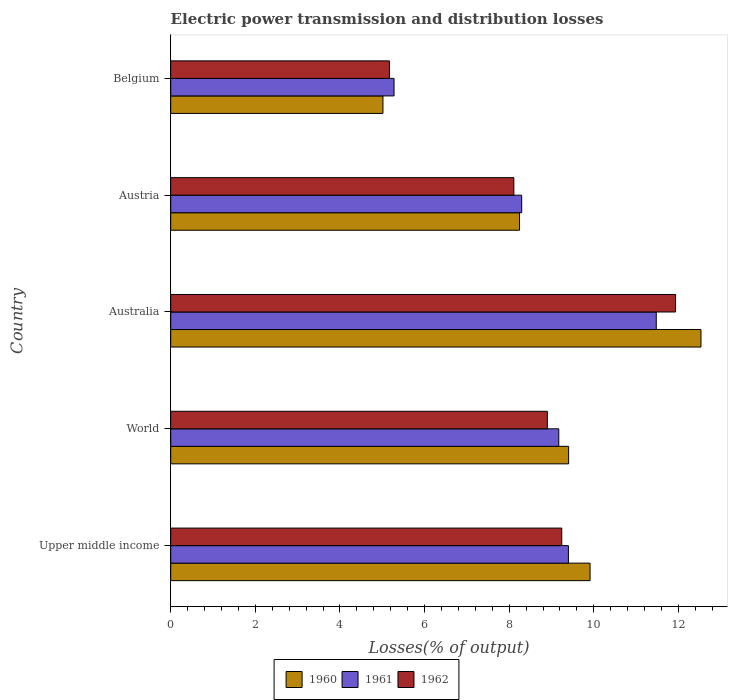How many different coloured bars are there?
Ensure brevity in your answer.  3. How many groups of bars are there?
Your answer should be very brief. 5. How many bars are there on the 4th tick from the top?
Provide a short and direct response. 3. What is the label of the 5th group of bars from the top?
Offer a very short reply. Upper middle income. What is the electric power transmission and distribution losses in 1960 in Australia?
Provide a short and direct response. 12.53. Across all countries, what is the maximum electric power transmission and distribution losses in 1962?
Provide a succinct answer. 11.93. Across all countries, what is the minimum electric power transmission and distribution losses in 1960?
Provide a succinct answer. 5.02. In which country was the electric power transmission and distribution losses in 1960 maximum?
Provide a succinct answer. Australia. In which country was the electric power transmission and distribution losses in 1960 minimum?
Offer a very short reply. Belgium. What is the total electric power transmission and distribution losses in 1961 in the graph?
Make the answer very short. 43.62. What is the difference between the electric power transmission and distribution losses in 1961 in Belgium and that in Upper middle income?
Provide a succinct answer. -4.12. What is the difference between the electric power transmission and distribution losses in 1961 in World and the electric power transmission and distribution losses in 1960 in Austria?
Keep it short and to the point. 0.93. What is the average electric power transmission and distribution losses in 1961 per country?
Your answer should be compact. 8.72. What is the difference between the electric power transmission and distribution losses in 1962 and electric power transmission and distribution losses in 1960 in Belgium?
Ensure brevity in your answer.  0.15. What is the ratio of the electric power transmission and distribution losses in 1962 in Belgium to that in Upper middle income?
Ensure brevity in your answer.  0.56. What is the difference between the highest and the second highest electric power transmission and distribution losses in 1960?
Give a very brief answer. 2.62. What is the difference between the highest and the lowest electric power transmission and distribution losses in 1962?
Your response must be concise. 6.76. In how many countries, is the electric power transmission and distribution losses in 1961 greater than the average electric power transmission and distribution losses in 1961 taken over all countries?
Make the answer very short. 3. What does the 2nd bar from the top in Austria represents?
Offer a terse response. 1961. Is it the case that in every country, the sum of the electric power transmission and distribution losses in 1960 and electric power transmission and distribution losses in 1961 is greater than the electric power transmission and distribution losses in 1962?
Your answer should be very brief. Yes. How many bars are there?
Give a very brief answer. 15. Are all the bars in the graph horizontal?
Give a very brief answer. Yes. Does the graph contain grids?
Make the answer very short. No. How are the legend labels stacked?
Your answer should be compact. Horizontal. What is the title of the graph?
Your answer should be very brief. Electric power transmission and distribution losses. What is the label or title of the X-axis?
Keep it short and to the point. Losses(% of output). What is the Losses(% of output) in 1960 in Upper middle income?
Ensure brevity in your answer.  9.91. What is the Losses(% of output) of 1961 in Upper middle income?
Your answer should be very brief. 9.4. What is the Losses(% of output) in 1962 in Upper middle income?
Provide a succinct answer. 9.24. What is the Losses(% of output) in 1960 in World?
Offer a very short reply. 9.4. What is the Losses(% of output) in 1961 in World?
Your answer should be very brief. 9.17. What is the Losses(% of output) in 1962 in World?
Give a very brief answer. 8.9. What is the Losses(% of output) of 1960 in Australia?
Your answer should be very brief. 12.53. What is the Losses(% of output) of 1961 in Australia?
Keep it short and to the point. 11.48. What is the Losses(% of output) of 1962 in Australia?
Ensure brevity in your answer.  11.93. What is the Losses(% of output) in 1960 in Austria?
Keep it short and to the point. 8.24. What is the Losses(% of output) in 1961 in Austria?
Keep it short and to the point. 8.3. What is the Losses(% of output) of 1962 in Austria?
Your response must be concise. 8.11. What is the Losses(% of output) in 1960 in Belgium?
Make the answer very short. 5.02. What is the Losses(% of output) in 1961 in Belgium?
Ensure brevity in your answer.  5.28. What is the Losses(% of output) in 1962 in Belgium?
Provide a short and direct response. 5.17. Across all countries, what is the maximum Losses(% of output) of 1960?
Keep it short and to the point. 12.53. Across all countries, what is the maximum Losses(% of output) in 1961?
Make the answer very short. 11.48. Across all countries, what is the maximum Losses(% of output) in 1962?
Offer a terse response. 11.93. Across all countries, what is the minimum Losses(% of output) in 1960?
Your answer should be very brief. 5.02. Across all countries, what is the minimum Losses(% of output) in 1961?
Ensure brevity in your answer.  5.28. Across all countries, what is the minimum Losses(% of output) of 1962?
Offer a very short reply. 5.17. What is the total Losses(% of output) in 1960 in the graph?
Keep it short and to the point. 45.11. What is the total Losses(% of output) in 1961 in the graph?
Your answer should be very brief. 43.62. What is the total Losses(% of output) in 1962 in the graph?
Your answer should be very brief. 43.35. What is the difference between the Losses(% of output) in 1960 in Upper middle income and that in World?
Make the answer very short. 0.51. What is the difference between the Losses(% of output) of 1961 in Upper middle income and that in World?
Make the answer very short. 0.23. What is the difference between the Losses(% of output) of 1962 in Upper middle income and that in World?
Ensure brevity in your answer.  0.34. What is the difference between the Losses(% of output) in 1960 in Upper middle income and that in Australia?
Your answer should be compact. -2.62. What is the difference between the Losses(% of output) in 1961 in Upper middle income and that in Australia?
Keep it short and to the point. -2.08. What is the difference between the Losses(% of output) of 1962 in Upper middle income and that in Australia?
Ensure brevity in your answer.  -2.69. What is the difference between the Losses(% of output) in 1960 in Upper middle income and that in Austria?
Offer a very short reply. 1.67. What is the difference between the Losses(% of output) of 1961 in Upper middle income and that in Austria?
Provide a succinct answer. 1.1. What is the difference between the Losses(% of output) in 1962 in Upper middle income and that in Austria?
Provide a short and direct response. 1.13. What is the difference between the Losses(% of output) of 1960 in Upper middle income and that in Belgium?
Your answer should be compact. 4.9. What is the difference between the Losses(% of output) in 1961 in Upper middle income and that in Belgium?
Make the answer very short. 4.12. What is the difference between the Losses(% of output) in 1962 in Upper middle income and that in Belgium?
Provide a succinct answer. 4.07. What is the difference between the Losses(% of output) of 1960 in World and that in Australia?
Offer a terse response. -3.13. What is the difference between the Losses(% of output) in 1961 in World and that in Australia?
Provide a short and direct response. -2.3. What is the difference between the Losses(% of output) of 1962 in World and that in Australia?
Your response must be concise. -3.03. What is the difference between the Losses(% of output) of 1960 in World and that in Austria?
Keep it short and to the point. 1.16. What is the difference between the Losses(% of output) in 1961 in World and that in Austria?
Your answer should be compact. 0.88. What is the difference between the Losses(% of output) in 1962 in World and that in Austria?
Provide a succinct answer. 0.79. What is the difference between the Losses(% of output) of 1960 in World and that in Belgium?
Offer a terse response. 4.39. What is the difference between the Losses(% of output) of 1961 in World and that in Belgium?
Your answer should be compact. 3.89. What is the difference between the Losses(% of output) of 1962 in World and that in Belgium?
Keep it short and to the point. 3.73. What is the difference between the Losses(% of output) of 1960 in Australia and that in Austria?
Make the answer very short. 4.29. What is the difference between the Losses(% of output) in 1961 in Australia and that in Austria?
Offer a terse response. 3.18. What is the difference between the Losses(% of output) of 1962 in Australia and that in Austria?
Your response must be concise. 3.82. What is the difference between the Losses(% of output) in 1960 in Australia and that in Belgium?
Your answer should be compact. 7.52. What is the difference between the Losses(% of output) in 1961 in Australia and that in Belgium?
Provide a short and direct response. 6.2. What is the difference between the Losses(% of output) in 1962 in Australia and that in Belgium?
Keep it short and to the point. 6.76. What is the difference between the Losses(% of output) of 1960 in Austria and that in Belgium?
Provide a short and direct response. 3.23. What is the difference between the Losses(% of output) in 1961 in Austria and that in Belgium?
Offer a terse response. 3.02. What is the difference between the Losses(% of output) of 1962 in Austria and that in Belgium?
Ensure brevity in your answer.  2.94. What is the difference between the Losses(% of output) of 1960 in Upper middle income and the Losses(% of output) of 1961 in World?
Offer a terse response. 0.74. What is the difference between the Losses(% of output) in 1960 in Upper middle income and the Losses(% of output) in 1962 in World?
Give a very brief answer. 1.01. What is the difference between the Losses(% of output) in 1961 in Upper middle income and the Losses(% of output) in 1962 in World?
Ensure brevity in your answer.  0.5. What is the difference between the Losses(% of output) of 1960 in Upper middle income and the Losses(% of output) of 1961 in Australia?
Your answer should be very brief. -1.56. What is the difference between the Losses(% of output) in 1960 in Upper middle income and the Losses(% of output) in 1962 in Australia?
Your answer should be very brief. -2.02. What is the difference between the Losses(% of output) of 1961 in Upper middle income and the Losses(% of output) of 1962 in Australia?
Give a very brief answer. -2.53. What is the difference between the Losses(% of output) in 1960 in Upper middle income and the Losses(% of output) in 1961 in Austria?
Keep it short and to the point. 1.62. What is the difference between the Losses(% of output) in 1960 in Upper middle income and the Losses(% of output) in 1962 in Austria?
Your answer should be compact. 1.8. What is the difference between the Losses(% of output) of 1961 in Upper middle income and the Losses(% of output) of 1962 in Austria?
Your answer should be compact. 1.29. What is the difference between the Losses(% of output) of 1960 in Upper middle income and the Losses(% of output) of 1961 in Belgium?
Make the answer very short. 4.63. What is the difference between the Losses(% of output) in 1960 in Upper middle income and the Losses(% of output) in 1962 in Belgium?
Give a very brief answer. 4.74. What is the difference between the Losses(% of output) in 1961 in Upper middle income and the Losses(% of output) in 1962 in Belgium?
Your response must be concise. 4.23. What is the difference between the Losses(% of output) of 1960 in World and the Losses(% of output) of 1961 in Australia?
Ensure brevity in your answer.  -2.07. What is the difference between the Losses(% of output) of 1960 in World and the Losses(% of output) of 1962 in Australia?
Your answer should be very brief. -2.53. What is the difference between the Losses(% of output) in 1961 in World and the Losses(% of output) in 1962 in Australia?
Provide a succinct answer. -2.76. What is the difference between the Losses(% of output) in 1960 in World and the Losses(% of output) in 1961 in Austria?
Keep it short and to the point. 1.11. What is the difference between the Losses(% of output) of 1960 in World and the Losses(% of output) of 1962 in Austria?
Offer a very short reply. 1.29. What is the difference between the Losses(% of output) in 1961 in World and the Losses(% of output) in 1962 in Austria?
Provide a succinct answer. 1.06. What is the difference between the Losses(% of output) of 1960 in World and the Losses(% of output) of 1961 in Belgium?
Your answer should be very brief. 4.13. What is the difference between the Losses(% of output) in 1960 in World and the Losses(% of output) in 1962 in Belgium?
Your answer should be very brief. 4.23. What is the difference between the Losses(% of output) of 1961 in World and the Losses(% of output) of 1962 in Belgium?
Offer a very short reply. 4. What is the difference between the Losses(% of output) of 1960 in Australia and the Losses(% of output) of 1961 in Austria?
Offer a very short reply. 4.24. What is the difference between the Losses(% of output) of 1960 in Australia and the Losses(% of output) of 1962 in Austria?
Make the answer very short. 4.42. What is the difference between the Losses(% of output) of 1961 in Australia and the Losses(% of output) of 1962 in Austria?
Provide a short and direct response. 3.37. What is the difference between the Losses(% of output) of 1960 in Australia and the Losses(% of output) of 1961 in Belgium?
Your response must be concise. 7.25. What is the difference between the Losses(% of output) of 1960 in Australia and the Losses(% of output) of 1962 in Belgium?
Provide a succinct answer. 7.36. What is the difference between the Losses(% of output) in 1961 in Australia and the Losses(% of output) in 1962 in Belgium?
Your answer should be very brief. 6.31. What is the difference between the Losses(% of output) in 1960 in Austria and the Losses(% of output) in 1961 in Belgium?
Keep it short and to the point. 2.97. What is the difference between the Losses(% of output) of 1960 in Austria and the Losses(% of output) of 1962 in Belgium?
Your answer should be very brief. 3.07. What is the difference between the Losses(% of output) of 1961 in Austria and the Losses(% of output) of 1962 in Belgium?
Your answer should be compact. 3.13. What is the average Losses(% of output) of 1960 per country?
Make the answer very short. 9.02. What is the average Losses(% of output) in 1961 per country?
Give a very brief answer. 8.72. What is the average Losses(% of output) of 1962 per country?
Your answer should be compact. 8.67. What is the difference between the Losses(% of output) of 1960 and Losses(% of output) of 1961 in Upper middle income?
Give a very brief answer. 0.51. What is the difference between the Losses(% of output) of 1960 and Losses(% of output) of 1962 in Upper middle income?
Make the answer very short. 0.67. What is the difference between the Losses(% of output) in 1961 and Losses(% of output) in 1962 in Upper middle income?
Your answer should be compact. 0.16. What is the difference between the Losses(% of output) of 1960 and Losses(% of output) of 1961 in World?
Keep it short and to the point. 0.23. What is the difference between the Losses(% of output) in 1960 and Losses(% of output) in 1962 in World?
Provide a succinct answer. 0.5. What is the difference between the Losses(% of output) in 1961 and Losses(% of output) in 1962 in World?
Give a very brief answer. 0.27. What is the difference between the Losses(% of output) in 1960 and Losses(% of output) in 1961 in Australia?
Provide a succinct answer. 1.06. What is the difference between the Losses(% of output) in 1960 and Losses(% of output) in 1962 in Australia?
Your answer should be very brief. 0.6. What is the difference between the Losses(% of output) in 1961 and Losses(% of output) in 1962 in Australia?
Your response must be concise. -0.46. What is the difference between the Losses(% of output) in 1960 and Losses(% of output) in 1961 in Austria?
Provide a short and direct response. -0.05. What is the difference between the Losses(% of output) in 1960 and Losses(% of output) in 1962 in Austria?
Provide a short and direct response. 0.13. What is the difference between the Losses(% of output) of 1961 and Losses(% of output) of 1962 in Austria?
Your response must be concise. 0.19. What is the difference between the Losses(% of output) in 1960 and Losses(% of output) in 1961 in Belgium?
Your answer should be very brief. -0.26. What is the difference between the Losses(% of output) of 1960 and Losses(% of output) of 1962 in Belgium?
Give a very brief answer. -0.15. What is the difference between the Losses(% of output) of 1961 and Losses(% of output) of 1962 in Belgium?
Give a very brief answer. 0.11. What is the ratio of the Losses(% of output) of 1960 in Upper middle income to that in World?
Keep it short and to the point. 1.05. What is the ratio of the Losses(% of output) of 1961 in Upper middle income to that in World?
Offer a terse response. 1.02. What is the ratio of the Losses(% of output) in 1962 in Upper middle income to that in World?
Keep it short and to the point. 1.04. What is the ratio of the Losses(% of output) in 1960 in Upper middle income to that in Australia?
Provide a succinct answer. 0.79. What is the ratio of the Losses(% of output) in 1961 in Upper middle income to that in Australia?
Your response must be concise. 0.82. What is the ratio of the Losses(% of output) of 1962 in Upper middle income to that in Australia?
Ensure brevity in your answer.  0.77. What is the ratio of the Losses(% of output) of 1960 in Upper middle income to that in Austria?
Offer a terse response. 1.2. What is the ratio of the Losses(% of output) in 1961 in Upper middle income to that in Austria?
Keep it short and to the point. 1.13. What is the ratio of the Losses(% of output) in 1962 in Upper middle income to that in Austria?
Your answer should be compact. 1.14. What is the ratio of the Losses(% of output) of 1960 in Upper middle income to that in Belgium?
Make the answer very short. 1.98. What is the ratio of the Losses(% of output) of 1961 in Upper middle income to that in Belgium?
Offer a very short reply. 1.78. What is the ratio of the Losses(% of output) in 1962 in Upper middle income to that in Belgium?
Your answer should be compact. 1.79. What is the ratio of the Losses(% of output) of 1960 in World to that in Australia?
Provide a short and direct response. 0.75. What is the ratio of the Losses(% of output) of 1961 in World to that in Australia?
Give a very brief answer. 0.8. What is the ratio of the Losses(% of output) of 1962 in World to that in Australia?
Provide a short and direct response. 0.75. What is the ratio of the Losses(% of output) of 1960 in World to that in Austria?
Give a very brief answer. 1.14. What is the ratio of the Losses(% of output) in 1961 in World to that in Austria?
Provide a succinct answer. 1.11. What is the ratio of the Losses(% of output) in 1962 in World to that in Austria?
Make the answer very short. 1.1. What is the ratio of the Losses(% of output) in 1960 in World to that in Belgium?
Give a very brief answer. 1.87. What is the ratio of the Losses(% of output) in 1961 in World to that in Belgium?
Offer a terse response. 1.74. What is the ratio of the Losses(% of output) in 1962 in World to that in Belgium?
Provide a succinct answer. 1.72. What is the ratio of the Losses(% of output) in 1960 in Australia to that in Austria?
Make the answer very short. 1.52. What is the ratio of the Losses(% of output) of 1961 in Australia to that in Austria?
Provide a succinct answer. 1.38. What is the ratio of the Losses(% of output) of 1962 in Australia to that in Austria?
Give a very brief answer. 1.47. What is the ratio of the Losses(% of output) in 1960 in Australia to that in Belgium?
Provide a succinct answer. 2.5. What is the ratio of the Losses(% of output) of 1961 in Australia to that in Belgium?
Offer a terse response. 2.17. What is the ratio of the Losses(% of output) in 1962 in Australia to that in Belgium?
Offer a terse response. 2.31. What is the ratio of the Losses(% of output) in 1960 in Austria to that in Belgium?
Keep it short and to the point. 1.64. What is the ratio of the Losses(% of output) of 1961 in Austria to that in Belgium?
Provide a succinct answer. 1.57. What is the ratio of the Losses(% of output) of 1962 in Austria to that in Belgium?
Your answer should be compact. 1.57. What is the difference between the highest and the second highest Losses(% of output) in 1960?
Your answer should be very brief. 2.62. What is the difference between the highest and the second highest Losses(% of output) in 1961?
Keep it short and to the point. 2.08. What is the difference between the highest and the second highest Losses(% of output) of 1962?
Your answer should be very brief. 2.69. What is the difference between the highest and the lowest Losses(% of output) of 1960?
Your answer should be compact. 7.52. What is the difference between the highest and the lowest Losses(% of output) of 1961?
Your response must be concise. 6.2. What is the difference between the highest and the lowest Losses(% of output) in 1962?
Offer a terse response. 6.76. 